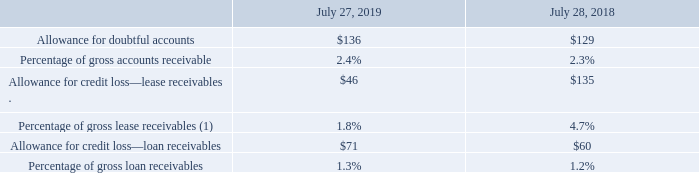Allowances for Receivables and Sales Returns
The allowances for receivables were as follows (in millions, except percentages):
(1) Calculated as allowance for credit loss on lease receivables as a percentage of gross lease receivables and residual value before unearned income.
The allowance for doubtful accounts is based on our assessment of the collectibility of customer accounts. We regularly review the adequacy of these allowances by considering internal factors such as historical experience, credit quality and age of the receivable balances as well as external factors such as economic conditions that may affect a customer’s ability to pay as well as historical and expected default frequency rates, which are published by major third-party credit-rating agencies and are updated on a quarterly basis. We also consider the concentration of receivables outstanding with a particular customer in assessing the adequacy of our allowances for doubtful accounts. If a major customer’s creditworthiness deteriorates, if actual defaults are higher than our historical experience, or if other circumstances arise, our estimates of the recoverability of amounts due to us could be overstated, and additional allowances could be required, which could have an adverse impact on our operating results.
The allowance for credit loss on financing receivables is also based on the assessment of collectibility of customer accounts. We regularly review the adequacy of the credit allowances determined either on an individual or a collective basis. When evaluating the financing receivables on an individual basis, we consider historical experience, credit quality and age of receivable balances, and economic conditions that may affect a customer’s ability to pay. When evaluating financing receivables on a collective basis, we use expected default frequency rates published by a major third-party credit-rating agency as well as our own historical loss rate in the event of default, while also systematically giving effect to economic conditions, concentration of risk and correlation. Determining expected default frequency rates and loss factors associated with internal credit risk ratings, as well as assessing factors such as economic conditions, concentration of risk, and correlation, are complex and subjective. Our ongoing consideration of all these factors could result in an increase in our allowance for credit loss in the future, which could adversely affect our operating results. Both accounts receivable and financing receivables are charged off at the point when they are considered uncollectible.
A reserve for future sales returns is established based on historical trends in product return rates. The reserve for future sales returns as of July 27, 2019 and July 28, 2018 was $84 million and $123 million, respectively, and was recorded as a reduction of our accounts receivable and revenue. If the actual future returns were to deviate from the historical data on which the reserve had been established, our revenue could be adversely affected.
How was the percentage of gross lease receivables calculated? As allowance for credit loss on lease receivables as a percentage of gross lease receivables and residual value before unearned income. What is the allowance for doubtful accounts based on? Our assessment of the collectibility of customer accounts. What was the Percentage of gross loan receivables in 2019?
Answer scale should be: percent. 1.3. What would be the change in Allowance for credit loss—loan receivables between 2018 and 2019?
Answer scale should be: million. 71-60
Answer: 11. How many years did Percentage of gross lease receivables exceed 2.0%? 2018
Answer: 1. What was the percentage change in Allowance for doubtful accounts between 2018 and 2019?
Answer scale should be: percent. (136-129)/129
Answer: 5.43. 